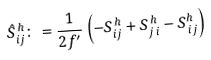<formula> <loc_0><loc_0><loc_500><loc_500>\hat { S } _ { i j } ^ { \, h } \colon = \frac { 1 } { 2 f ^ { \prime } } \/ \left ( - S _ { i j } ^ { \, h } + S _ { j \, i } ^ { \, h } - S ^ { h } _ { \, i j } \right )</formula> 